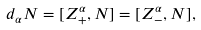<formula> <loc_0><loc_0><loc_500><loc_500>d _ { \alpha } N = [ Z _ { + } ^ { \alpha } , N ] = [ Z _ { - } ^ { \alpha } , N ] ,</formula> 